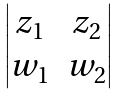<formula> <loc_0><loc_0><loc_500><loc_500>\begin{vmatrix} z _ { 1 } & z _ { 2 } \\ w _ { 1 } & w _ { 2 } \end{vmatrix}</formula> 